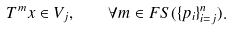Convert formula to latex. <formula><loc_0><loc_0><loc_500><loc_500>T ^ { m } x \in V _ { j } , \quad \forall m \in F S ( \{ p _ { i } \} _ { i = j } ^ { n } ) .</formula> 